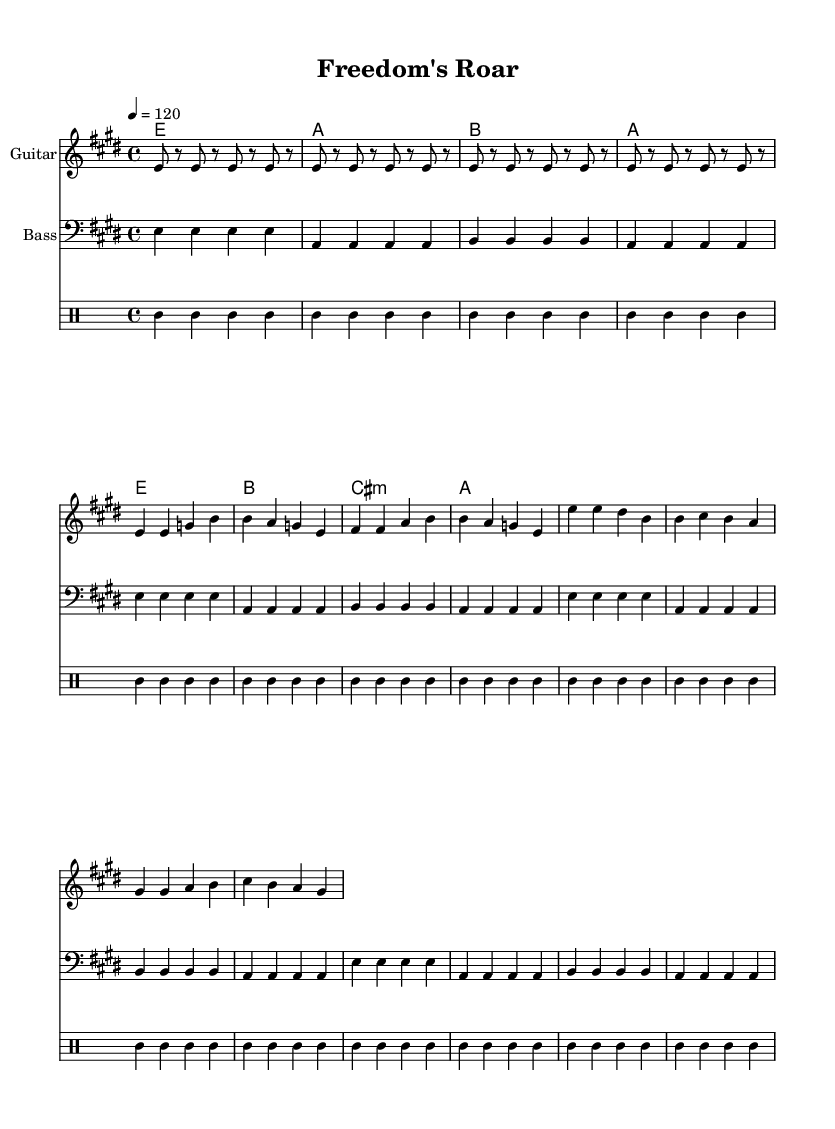What is the key signature of this music? The key signature is E major, which has four sharps (F#, C#, G#, and D#). This is indicated at the beginning of the sheet music, where the key signature is shown.
Answer: E major What is the time signature used in this sheet music? The time signature is 4/4, which is indicated at the beginning of the score. This signature means there are four beats in a measure and the quarter note receives one beat.
Answer: 4/4 What is the tempo marking for this piece? The tempo marking is 120 beats per minute, shown in the score as "4 = 120." This indicates how fast the music should be played, specifically that there are 120 quarter notes per minute.
Answer: 120 How many measures are there in the verse section? The verse section has four measures, as indicated by the melody and chord structure provided. Each segment of the melody or chords usually corresponds to one measure, which is visually clear when counting the notated sections.
Answer: 4 What instrument is indicated for the first staff? The first staff is indicated for the Guitar, as shown in the instrument name provided at the beginning of that staff. This informs the musician which instrument the section is intended for.
Answer: Guitar What repeated musical figure can be found in the guitar riff? The guitar riff contains a repeated pattern of an eighth note followed by rest for the note E. This is indicated by the repeated unfolding of the eighth notes and rests throughout the section.
Answer: E 